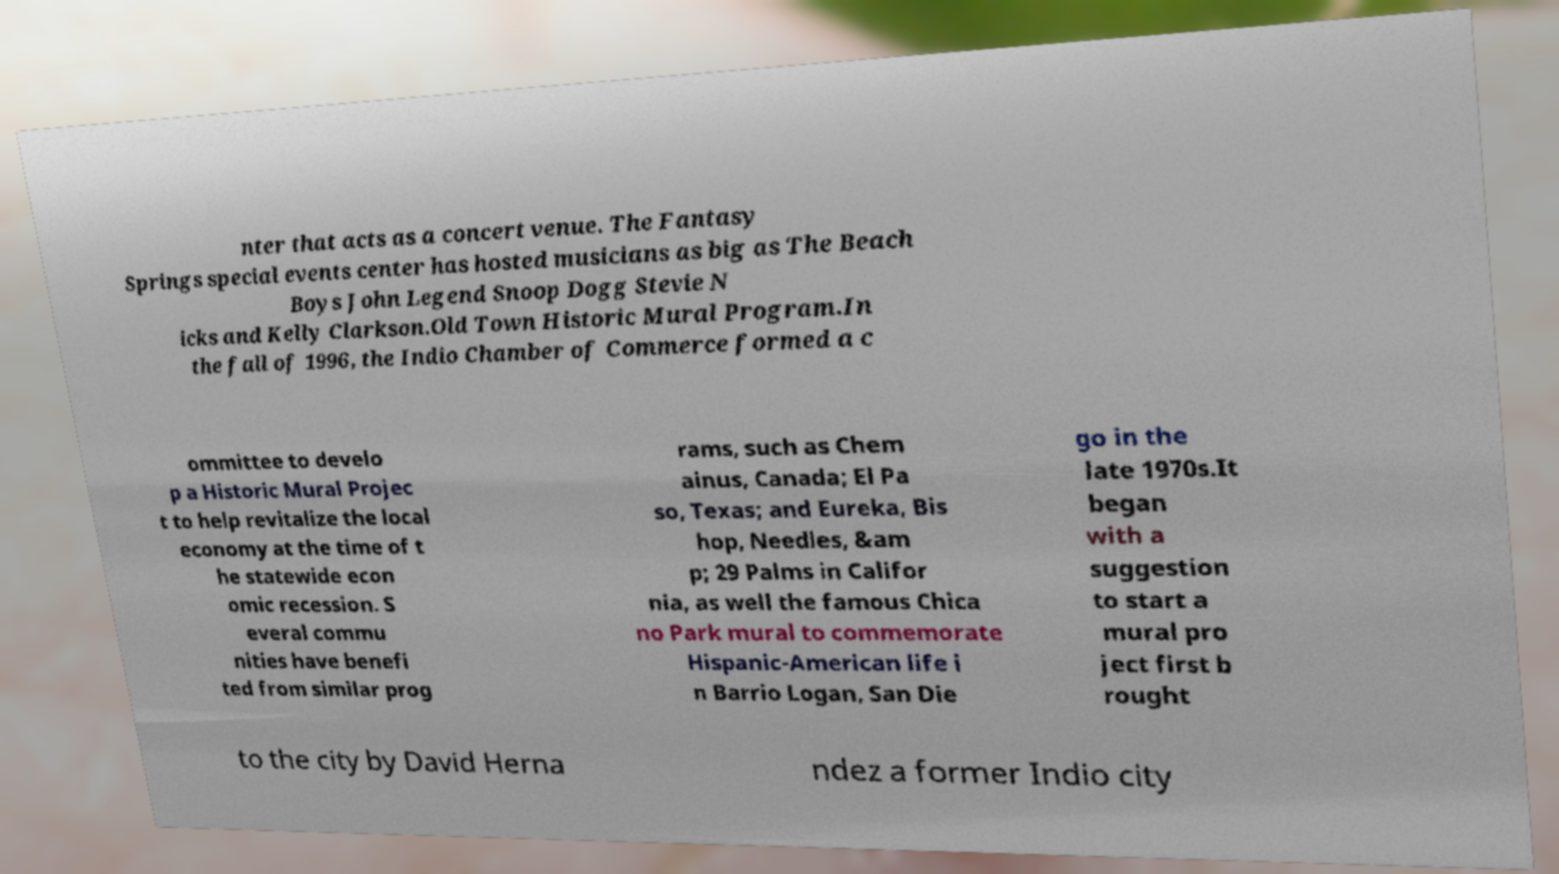Please read and relay the text visible in this image. What does it say? nter that acts as a concert venue. The Fantasy Springs special events center has hosted musicians as big as The Beach Boys John Legend Snoop Dogg Stevie N icks and Kelly Clarkson.Old Town Historic Mural Program.In the fall of 1996, the Indio Chamber of Commerce formed a c ommittee to develo p a Historic Mural Projec t to help revitalize the local economy at the time of t he statewide econ omic recession. S everal commu nities have benefi ted from similar prog rams, such as Chem ainus, Canada; El Pa so, Texas; and Eureka, Bis hop, Needles, &am p; 29 Palms in Califor nia, as well the famous Chica no Park mural to commemorate Hispanic-American life i n Barrio Logan, San Die go in the late 1970s.It began with a suggestion to start a mural pro ject first b rought to the city by David Herna ndez a former Indio city 